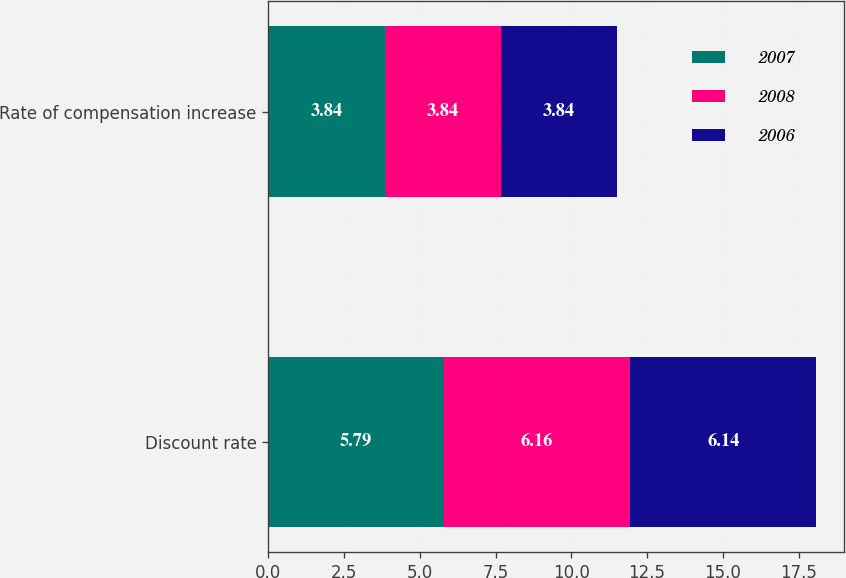<chart> <loc_0><loc_0><loc_500><loc_500><stacked_bar_chart><ecel><fcel>Discount rate<fcel>Rate of compensation increase<nl><fcel>2007<fcel>5.79<fcel>3.84<nl><fcel>2008<fcel>6.16<fcel>3.84<nl><fcel>2006<fcel>6.14<fcel>3.84<nl></chart> 